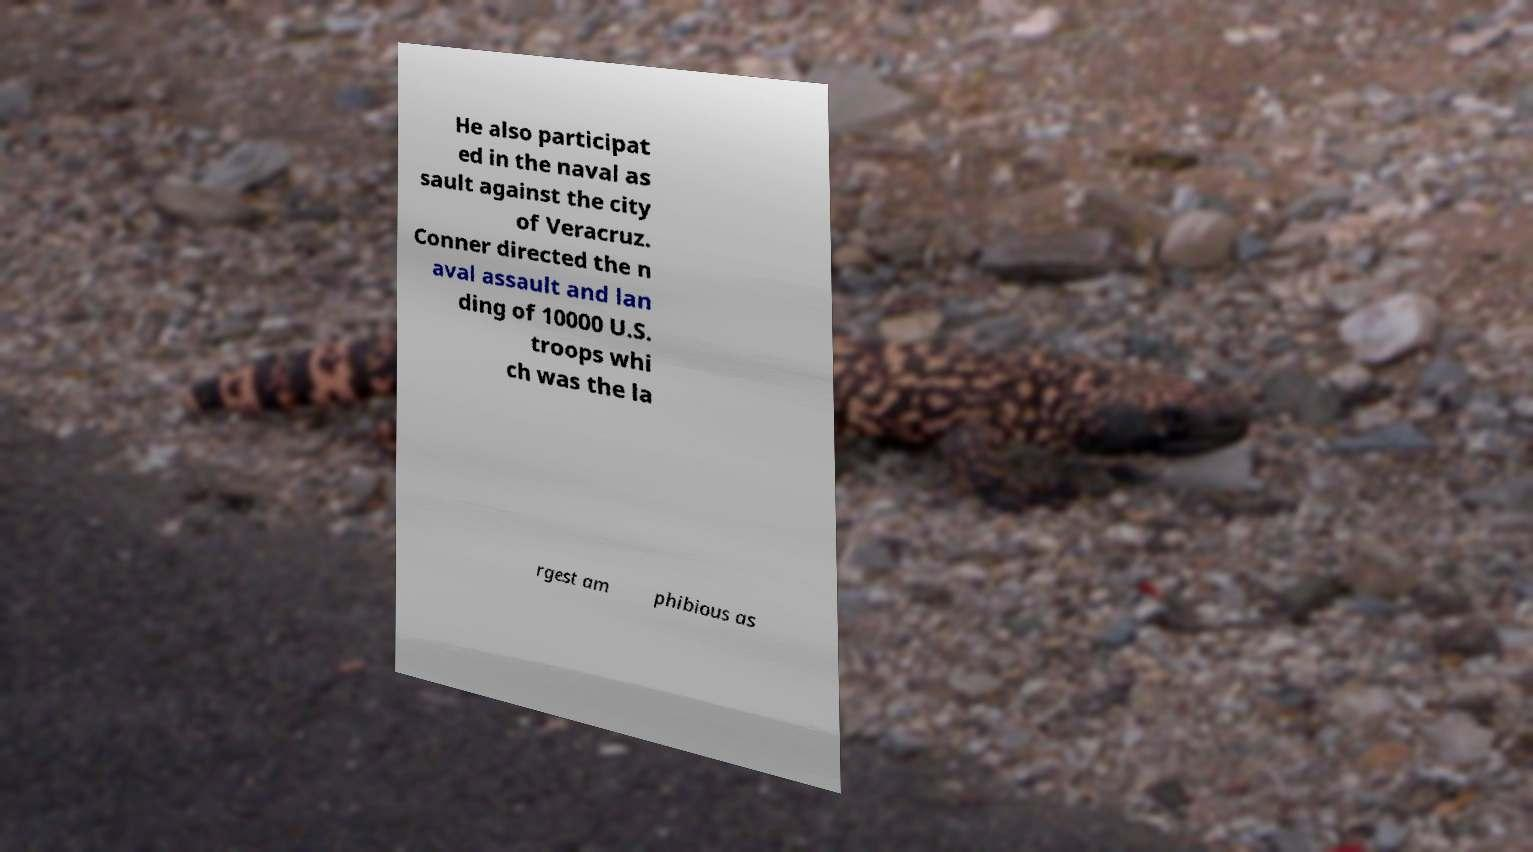Please read and relay the text visible in this image. What does it say? He also participat ed in the naval as sault against the city of Veracruz. Conner directed the n aval assault and lan ding of 10000 U.S. troops whi ch was the la rgest am phibious as 